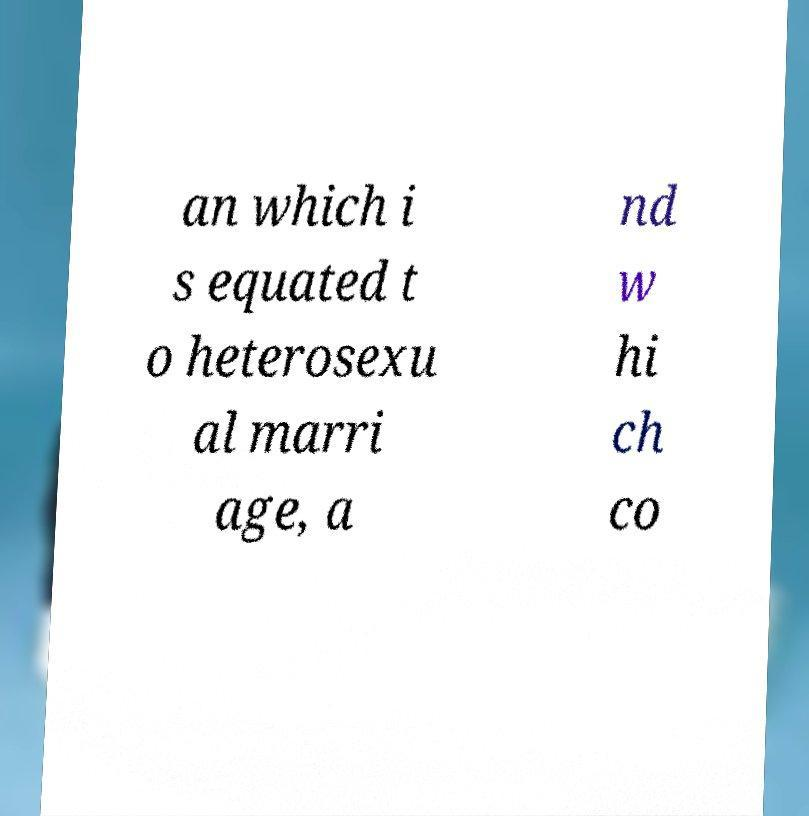Could you extract and type out the text from this image? an which i s equated t o heterosexu al marri age, a nd w hi ch co 